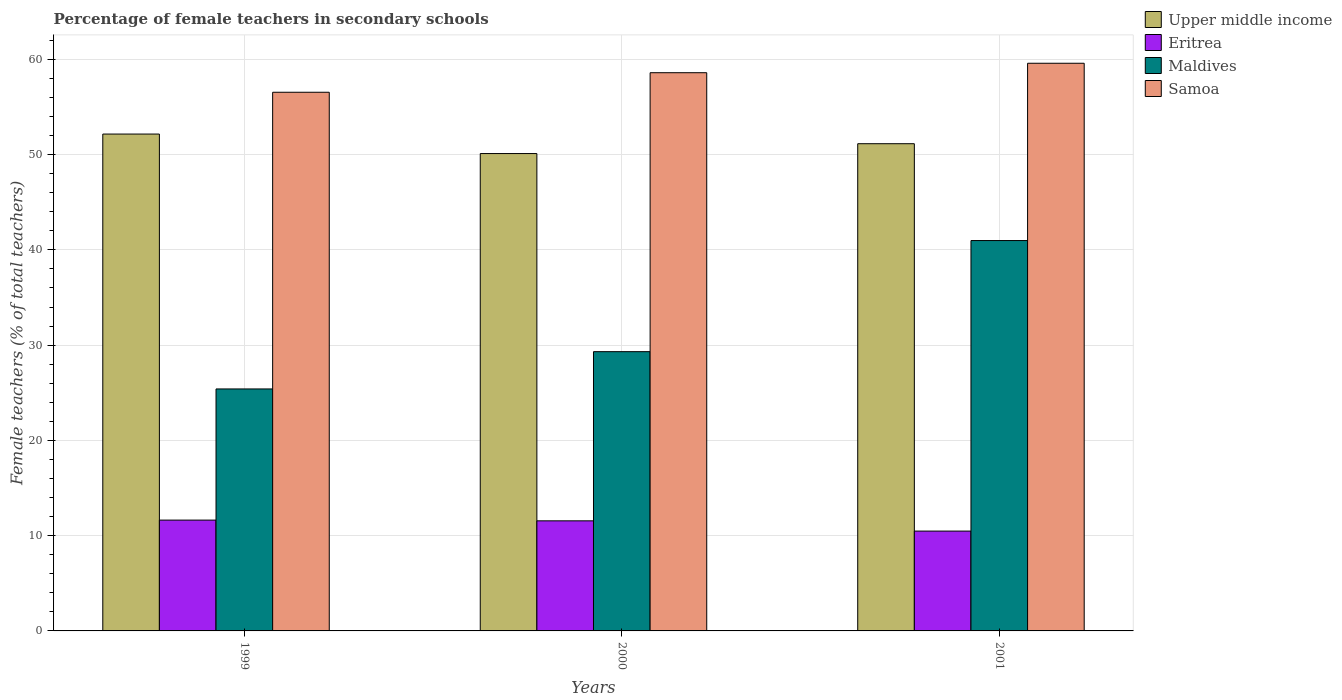Are the number of bars per tick equal to the number of legend labels?
Your answer should be compact. Yes. Are the number of bars on each tick of the X-axis equal?
Provide a short and direct response. Yes. How many bars are there on the 1st tick from the left?
Your answer should be compact. 4. How many bars are there on the 1st tick from the right?
Ensure brevity in your answer.  4. In how many cases, is the number of bars for a given year not equal to the number of legend labels?
Make the answer very short. 0. What is the percentage of female teachers in Samoa in 2001?
Ensure brevity in your answer.  59.59. Across all years, what is the maximum percentage of female teachers in Upper middle income?
Ensure brevity in your answer.  52.15. Across all years, what is the minimum percentage of female teachers in Samoa?
Keep it short and to the point. 56.54. In which year was the percentage of female teachers in Maldives maximum?
Offer a very short reply. 2001. What is the total percentage of female teachers in Upper middle income in the graph?
Keep it short and to the point. 153.41. What is the difference between the percentage of female teachers in Eritrea in 1999 and that in 2001?
Ensure brevity in your answer.  1.15. What is the difference between the percentage of female teachers in Eritrea in 2000 and the percentage of female teachers in Upper middle income in 1999?
Your answer should be compact. -40.6. What is the average percentage of female teachers in Upper middle income per year?
Provide a succinct answer. 51.14. In the year 1999, what is the difference between the percentage of female teachers in Samoa and percentage of female teachers in Eritrea?
Make the answer very short. 44.91. In how many years, is the percentage of female teachers in Eritrea greater than 44 %?
Your response must be concise. 0. What is the ratio of the percentage of female teachers in Eritrea in 1999 to that in 2000?
Ensure brevity in your answer.  1.01. Is the percentage of female teachers in Maldives in 1999 less than that in 2000?
Ensure brevity in your answer.  Yes. Is the difference between the percentage of female teachers in Samoa in 1999 and 2000 greater than the difference between the percentage of female teachers in Eritrea in 1999 and 2000?
Your answer should be compact. No. What is the difference between the highest and the second highest percentage of female teachers in Upper middle income?
Make the answer very short. 1.01. What is the difference between the highest and the lowest percentage of female teachers in Upper middle income?
Offer a terse response. 2.05. In how many years, is the percentage of female teachers in Maldives greater than the average percentage of female teachers in Maldives taken over all years?
Keep it short and to the point. 1. What does the 1st bar from the left in 2000 represents?
Provide a succinct answer. Upper middle income. What does the 4th bar from the right in 1999 represents?
Your answer should be compact. Upper middle income. How many bars are there?
Provide a succinct answer. 12. Are all the bars in the graph horizontal?
Offer a terse response. No. How many years are there in the graph?
Your answer should be very brief. 3. Does the graph contain grids?
Keep it short and to the point. Yes. How are the legend labels stacked?
Offer a terse response. Vertical. What is the title of the graph?
Provide a succinct answer. Percentage of female teachers in secondary schools. What is the label or title of the Y-axis?
Make the answer very short. Female teachers (% of total teachers). What is the Female teachers (% of total teachers) in Upper middle income in 1999?
Your answer should be very brief. 52.15. What is the Female teachers (% of total teachers) of Eritrea in 1999?
Ensure brevity in your answer.  11.63. What is the Female teachers (% of total teachers) in Maldives in 1999?
Keep it short and to the point. 25.4. What is the Female teachers (% of total teachers) of Samoa in 1999?
Offer a terse response. 56.54. What is the Female teachers (% of total teachers) in Upper middle income in 2000?
Offer a very short reply. 50.11. What is the Female teachers (% of total teachers) of Eritrea in 2000?
Your response must be concise. 11.56. What is the Female teachers (% of total teachers) in Maldives in 2000?
Your response must be concise. 29.31. What is the Female teachers (% of total teachers) in Samoa in 2000?
Your answer should be compact. 58.59. What is the Female teachers (% of total teachers) of Upper middle income in 2001?
Your answer should be very brief. 51.14. What is the Female teachers (% of total teachers) in Eritrea in 2001?
Provide a succinct answer. 10.48. What is the Female teachers (% of total teachers) of Maldives in 2001?
Provide a short and direct response. 40.98. What is the Female teachers (% of total teachers) of Samoa in 2001?
Your response must be concise. 59.59. Across all years, what is the maximum Female teachers (% of total teachers) of Upper middle income?
Your response must be concise. 52.15. Across all years, what is the maximum Female teachers (% of total teachers) of Eritrea?
Your answer should be very brief. 11.63. Across all years, what is the maximum Female teachers (% of total teachers) in Maldives?
Your response must be concise. 40.98. Across all years, what is the maximum Female teachers (% of total teachers) of Samoa?
Give a very brief answer. 59.59. Across all years, what is the minimum Female teachers (% of total teachers) of Upper middle income?
Ensure brevity in your answer.  50.11. Across all years, what is the minimum Female teachers (% of total teachers) in Eritrea?
Your answer should be compact. 10.48. Across all years, what is the minimum Female teachers (% of total teachers) in Maldives?
Keep it short and to the point. 25.4. Across all years, what is the minimum Female teachers (% of total teachers) in Samoa?
Give a very brief answer. 56.54. What is the total Female teachers (% of total teachers) of Upper middle income in the graph?
Your response must be concise. 153.41. What is the total Female teachers (% of total teachers) of Eritrea in the graph?
Your response must be concise. 33.67. What is the total Female teachers (% of total teachers) of Maldives in the graph?
Provide a short and direct response. 95.69. What is the total Female teachers (% of total teachers) in Samoa in the graph?
Make the answer very short. 174.72. What is the difference between the Female teachers (% of total teachers) in Upper middle income in 1999 and that in 2000?
Your response must be concise. 2.05. What is the difference between the Female teachers (% of total teachers) of Eritrea in 1999 and that in 2000?
Provide a succinct answer. 0.08. What is the difference between the Female teachers (% of total teachers) in Maldives in 1999 and that in 2000?
Offer a terse response. -3.91. What is the difference between the Female teachers (% of total teachers) in Samoa in 1999 and that in 2000?
Offer a terse response. -2.05. What is the difference between the Female teachers (% of total teachers) in Upper middle income in 1999 and that in 2001?
Your answer should be very brief. 1.01. What is the difference between the Female teachers (% of total teachers) of Eritrea in 1999 and that in 2001?
Provide a short and direct response. 1.15. What is the difference between the Female teachers (% of total teachers) in Maldives in 1999 and that in 2001?
Keep it short and to the point. -15.58. What is the difference between the Female teachers (% of total teachers) of Samoa in 1999 and that in 2001?
Offer a terse response. -3.04. What is the difference between the Female teachers (% of total teachers) in Upper middle income in 2000 and that in 2001?
Make the answer very short. -1.03. What is the difference between the Female teachers (% of total teachers) in Eritrea in 2000 and that in 2001?
Provide a succinct answer. 1.08. What is the difference between the Female teachers (% of total teachers) of Maldives in 2000 and that in 2001?
Offer a very short reply. -11.66. What is the difference between the Female teachers (% of total teachers) in Samoa in 2000 and that in 2001?
Your answer should be very brief. -0.99. What is the difference between the Female teachers (% of total teachers) of Upper middle income in 1999 and the Female teachers (% of total teachers) of Eritrea in 2000?
Ensure brevity in your answer.  40.6. What is the difference between the Female teachers (% of total teachers) in Upper middle income in 1999 and the Female teachers (% of total teachers) in Maldives in 2000?
Make the answer very short. 22.84. What is the difference between the Female teachers (% of total teachers) in Upper middle income in 1999 and the Female teachers (% of total teachers) in Samoa in 2000?
Provide a short and direct response. -6.44. What is the difference between the Female teachers (% of total teachers) in Eritrea in 1999 and the Female teachers (% of total teachers) in Maldives in 2000?
Keep it short and to the point. -17.68. What is the difference between the Female teachers (% of total teachers) in Eritrea in 1999 and the Female teachers (% of total teachers) in Samoa in 2000?
Provide a succinct answer. -46.96. What is the difference between the Female teachers (% of total teachers) in Maldives in 1999 and the Female teachers (% of total teachers) in Samoa in 2000?
Ensure brevity in your answer.  -33.19. What is the difference between the Female teachers (% of total teachers) of Upper middle income in 1999 and the Female teachers (% of total teachers) of Eritrea in 2001?
Ensure brevity in your answer.  41.67. What is the difference between the Female teachers (% of total teachers) in Upper middle income in 1999 and the Female teachers (% of total teachers) in Maldives in 2001?
Keep it short and to the point. 11.18. What is the difference between the Female teachers (% of total teachers) of Upper middle income in 1999 and the Female teachers (% of total teachers) of Samoa in 2001?
Your answer should be very brief. -7.43. What is the difference between the Female teachers (% of total teachers) of Eritrea in 1999 and the Female teachers (% of total teachers) of Maldives in 2001?
Offer a very short reply. -29.34. What is the difference between the Female teachers (% of total teachers) in Eritrea in 1999 and the Female teachers (% of total teachers) in Samoa in 2001?
Provide a succinct answer. -47.95. What is the difference between the Female teachers (% of total teachers) of Maldives in 1999 and the Female teachers (% of total teachers) of Samoa in 2001?
Offer a very short reply. -34.19. What is the difference between the Female teachers (% of total teachers) of Upper middle income in 2000 and the Female teachers (% of total teachers) of Eritrea in 2001?
Your answer should be compact. 39.63. What is the difference between the Female teachers (% of total teachers) of Upper middle income in 2000 and the Female teachers (% of total teachers) of Maldives in 2001?
Give a very brief answer. 9.13. What is the difference between the Female teachers (% of total teachers) of Upper middle income in 2000 and the Female teachers (% of total teachers) of Samoa in 2001?
Make the answer very short. -9.48. What is the difference between the Female teachers (% of total teachers) in Eritrea in 2000 and the Female teachers (% of total teachers) in Maldives in 2001?
Ensure brevity in your answer.  -29.42. What is the difference between the Female teachers (% of total teachers) in Eritrea in 2000 and the Female teachers (% of total teachers) in Samoa in 2001?
Your answer should be very brief. -48.03. What is the difference between the Female teachers (% of total teachers) in Maldives in 2000 and the Female teachers (% of total teachers) in Samoa in 2001?
Offer a terse response. -30.27. What is the average Female teachers (% of total teachers) in Upper middle income per year?
Your answer should be compact. 51.14. What is the average Female teachers (% of total teachers) of Eritrea per year?
Give a very brief answer. 11.22. What is the average Female teachers (% of total teachers) of Maldives per year?
Make the answer very short. 31.9. What is the average Female teachers (% of total teachers) of Samoa per year?
Give a very brief answer. 58.24. In the year 1999, what is the difference between the Female teachers (% of total teachers) of Upper middle income and Female teachers (% of total teachers) of Eritrea?
Give a very brief answer. 40.52. In the year 1999, what is the difference between the Female teachers (% of total teachers) in Upper middle income and Female teachers (% of total teachers) in Maldives?
Provide a short and direct response. 26.75. In the year 1999, what is the difference between the Female teachers (% of total teachers) in Upper middle income and Female teachers (% of total teachers) in Samoa?
Provide a succinct answer. -4.39. In the year 1999, what is the difference between the Female teachers (% of total teachers) of Eritrea and Female teachers (% of total teachers) of Maldives?
Provide a succinct answer. -13.77. In the year 1999, what is the difference between the Female teachers (% of total teachers) in Eritrea and Female teachers (% of total teachers) in Samoa?
Make the answer very short. -44.91. In the year 1999, what is the difference between the Female teachers (% of total teachers) in Maldives and Female teachers (% of total teachers) in Samoa?
Your response must be concise. -31.14. In the year 2000, what is the difference between the Female teachers (% of total teachers) of Upper middle income and Female teachers (% of total teachers) of Eritrea?
Your response must be concise. 38.55. In the year 2000, what is the difference between the Female teachers (% of total teachers) of Upper middle income and Female teachers (% of total teachers) of Maldives?
Ensure brevity in your answer.  20.8. In the year 2000, what is the difference between the Female teachers (% of total teachers) in Upper middle income and Female teachers (% of total teachers) in Samoa?
Make the answer very short. -8.48. In the year 2000, what is the difference between the Female teachers (% of total teachers) in Eritrea and Female teachers (% of total teachers) in Maldives?
Make the answer very short. -17.76. In the year 2000, what is the difference between the Female teachers (% of total teachers) in Eritrea and Female teachers (% of total teachers) in Samoa?
Give a very brief answer. -47.04. In the year 2000, what is the difference between the Female teachers (% of total teachers) of Maldives and Female teachers (% of total teachers) of Samoa?
Give a very brief answer. -29.28. In the year 2001, what is the difference between the Female teachers (% of total teachers) in Upper middle income and Female teachers (% of total teachers) in Eritrea?
Make the answer very short. 40.66. In the year 2001, what is the difference between the Female teachers (% of total teachers) in Upper middle income and Female teachers (% of total teachers) in Maldives?
Offer a terse response. 10.17. In the year 2001, what is the difference between the Female teachers (% of total teachers) of Upper middle income and Female teachers (% of total teachers) of Samoa?
Keep it short and to the point. -8.44. In the year 2001, what is the difference between the Female teachers (% of total teachers) of Eritrea and Female teachers (% of total teachers) of Maldives?
Offer a terse response. -30.5. In the year 2001, what is the difference between the Female teachers (% of total teachers) of Eritrea and Female teachers (% of total teachers) of Samoa?
Make the answer very short. -49.11. In the year 2001, what is the difference between the Female teachers (% of total teachers) of Maldives and Female teachers (% of total teachers) of Samoa?
Provide a succinct answer. -18.61. What is the ratio of the Female teachers (% of total teachers) of Upper middle income in 1999 to that in 2000?
Provide a short and direct response. 1.04. What is the ratio of the Female teachers (% of total teachers) of Maldives in 1999 to that in 2000?
Your response must be concise. 0.87. What is the ratio of the Female teachers (% of total teachers) of Samoa in 1999 to that in 2000?
Make the answer very short. 0.96. What is the ratio of the Female teachers (% of total teachers) of Upper middle income in 1999 to that in 2001?
Offer a very short reply. 1.02. What is the ratio of the Female teachers (% of total teachers) in Eritrea in 1999 to that in 2001?
Keep it short and to the point. 1.11. What is the ratio of the Female teachers (% of total teachers) of Maldives in 1999 to that in 2001?
Provide a short and direct response. 0.62. What is the ratio of the Female teachers (% of total teachers) of Samoa in 1999 to that in 2001?
Your answer should be compact. 0.95. What is the ratio of the Female teachers (% of total teachers) in Upper middle income in 2000 to that in 2001?
Give a very brief answer. 0.98. What is the ratio of the Female teachers (% of total teachers) in Eritrea in 2000 to that in 2001?
Provide a short and direct response. 1.1. What is the ratio of the Female teachers (% of total teachers) in Maldives in 2000 to that in 2001?
Your answer should be very brief. 0.72. What is the ratio of the Female teachers (% of total teachers) in Samoa in 2000 to that in 2001?
Give a very brief answer. 0.98. What is the difference between the highest and the second highest Female teachers (% of total teachers) of Upper middle income?
Provide a succinct answer. 1.01. What is the difference between the highest and the second highest Female teachers (% of total teachers) in Eritrea?
Offer a very short reply. 0.08. What is the difference between the highest and the second highest Female teachers (% of total teachers) in Maldives?
Offer a very short reply. 11.66. What is the difference between the highest and the second highest Female teachers (% of total teachers) in Samoa?
Keep it short and to the point. 0.99. What is the difference between the highest and the lowest Female teachers (% of total teachers) of Upper middle income?
Make the answer very short. 2.05. What is the difference between the highest and the lowest Female teachers (% of total teachers) of Eritrea?
Offer a very short reply. 1.15. What is the difference between the highest and the lowest Female teachers (% of total teachers) in Maldives?
Provide a short and direct response. 15.58. What is the difference between the highest and the lowest Female teachers (% of total teachers) in Samoa?
Your answer should be very brief. 3.04. 